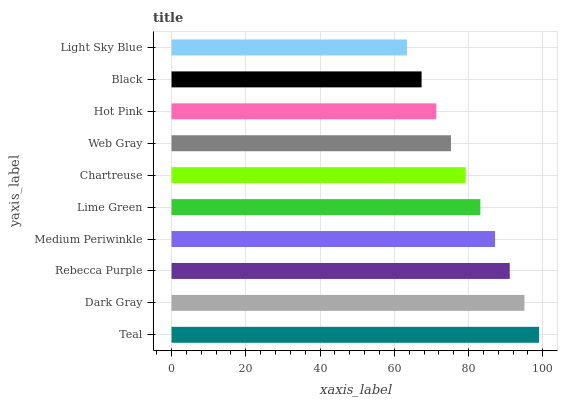Is Light Sky Blue the minimum?
Answer yes or no. Yes. Is Teal the maximum?
Answer yes or no. Yes. Is Dark Gray the minimum?
Answer yes or no. No. Is Dark Gray the maximum?
Answer yes or no. No. Is Teal greater than Dark Gray?
Answer yes or no. Yes. Is Dark Gray less than Teal?
Answer yes or no. Yes. Is Dark Gray greater than Teal?
Answer yes or no. No. Is Teal less than Dark Gray?
Answer yes or no. No. Is Lime Green the high median?
Answer yes or no. Yes. Is Chartreuse the low median?
Answer yes or no. Yes. Is Chartreuse the high median?
Answer yes or no. No. Is Web Gray the low median?
Answer yes or no. No. 